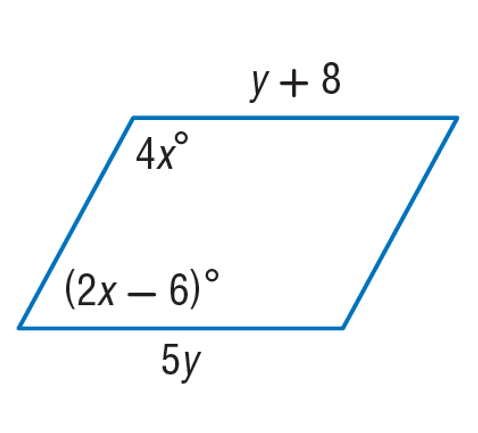Answer the mathemtical geometry problem and directly provide the correct option letter.
Question: Find y in the given parallelogram.
Choices: A: 2 B: 10 C: 31 D: 149 A 